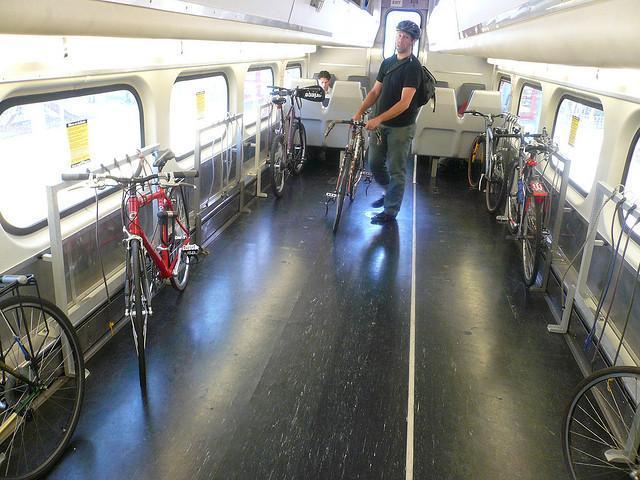How many bikes are there?
Give a very brief answer. 7. How many people are in the picture?
Give a very brief answer. 2. How many people are there?
Give a very brief answer. 1. How many bicycles can you see?
Give a very brief answer. 7. 